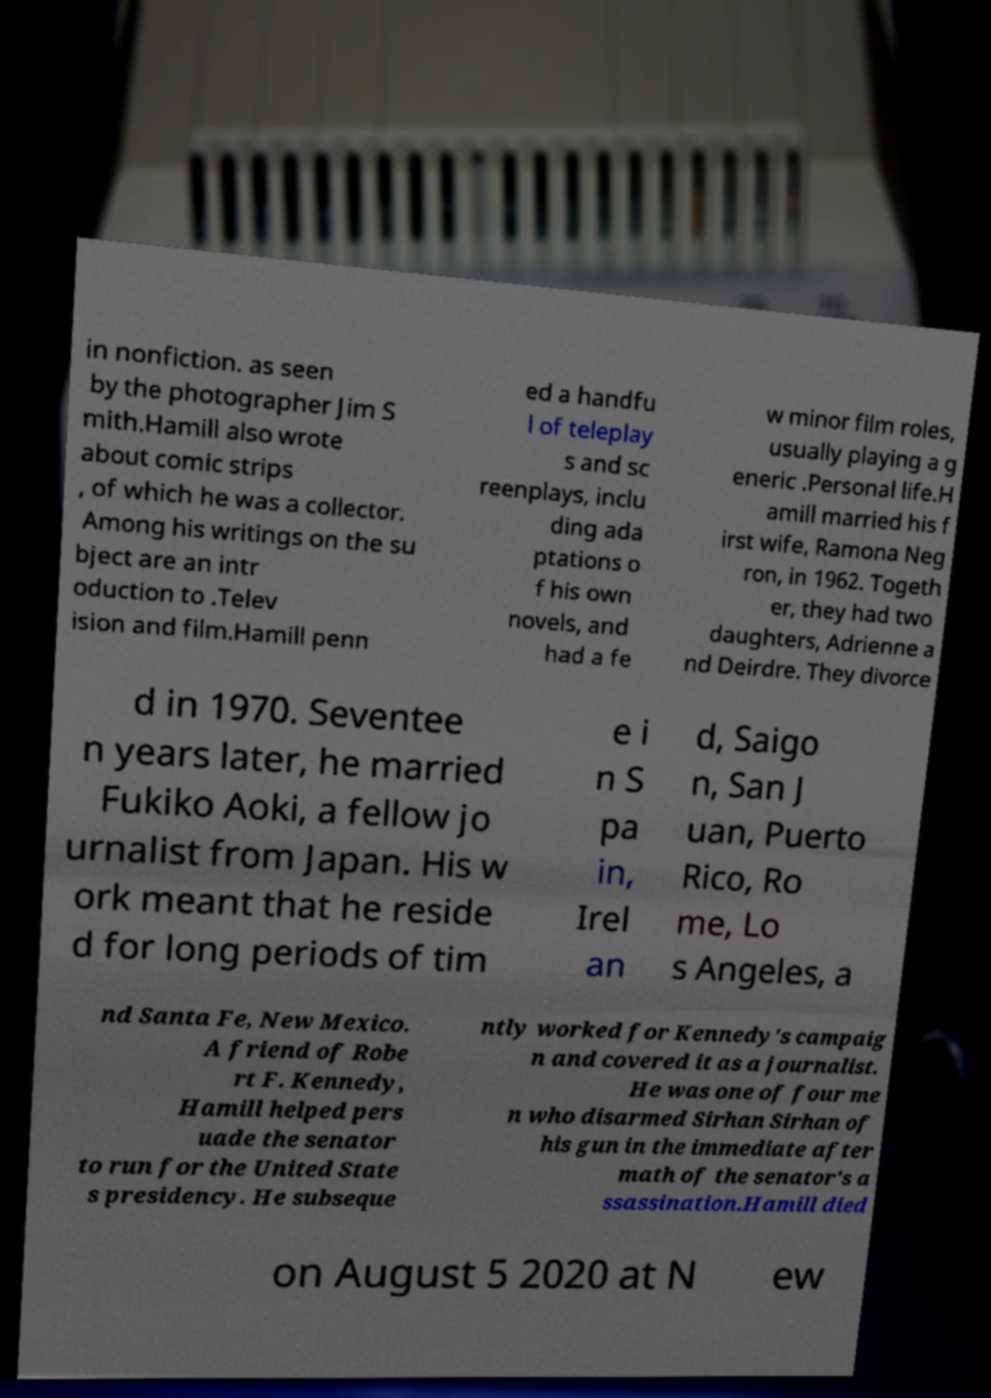I need the written content from this picture converted into text. Can you do that? in nonfiction. as seen by the photographer Jim S mith.Hamill also wrote about comic strips , of which he was a collector. Among his writings on the su bject are an intr oduction to .Telev ision and film.Hamill penn ed a handfu l of teleplay s and sc reenplays, inclu ding ada ptations o f his own novels, and had a fe w minor film roles, usually playing a g eneric .Personal life.H amill married his f irst wife, Ramona Neg ron, in 1962. Togeth er, they had two daughters, Adrienne a nd Deirdre. They divorce d in 1970. Seventee n years later, he married Fukiko Aoki, a fellow jo urnalist from Japan. His w ork meant that he reside d for long periods of tim e i n S pa in, Irel an d, Saigo n, San J uan, Puerto Rico, Ro me, Lo s Angeles, a nd Santa Fe, New Mexico. A friend of Robe rt F. Kennedy, Hamill helped pers uade the senator to run for the United State s presidency. He subseque ntly worked for Kennedy's campaig n and covered it as a journalist. He was one of four me n who disarmed Sirhan Sirhan of his gun in the immediate after math of the senator's a ssassination.Hamill died on August 5 2020 at N ew 